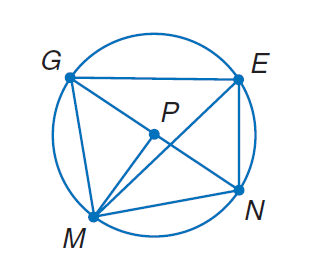Question: In \odot P, m \widehat E N = 66 and m \angle G P M = 89. Find m \angle G M E.
Choices:
A. 57
B. 66
C. 89
D. 155
Answer with the letter. Answer: A Question: In \odot P, m \widehat E N = 66 and m \angle G P M = 89. Find m \angle G N M.
Choices:
A. 44.5
B. 66
C. 89
D. 155
Answer with the letter. Answer: A Question: In \odot P, m \widehat E N = 66 and m \angle G P M = 89. Find m \angle E G N.
Choices:
A. 33
B. 66
C. 89
D. 155
Answer with the letter. Answer: A 